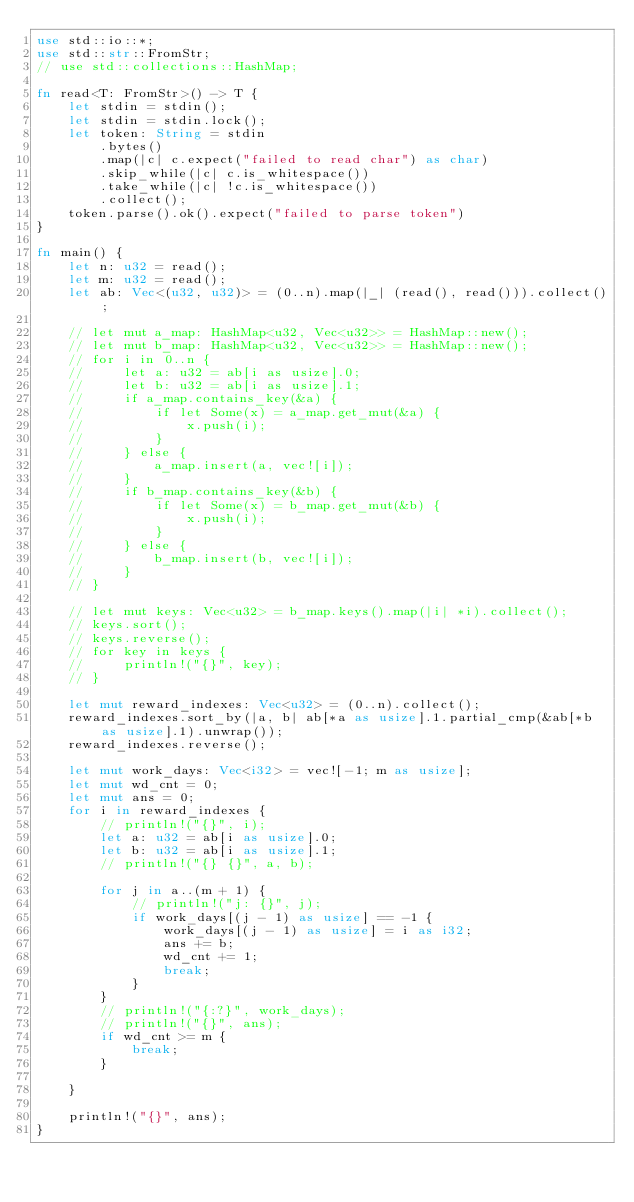Convert code to text. <code><loc_0><loc_0><loc_500><loc_500><_Rust_>use std::io::*;
use std::str::FromStr;
// use std::collections::HashMap;

fn read<T: FromStr>() -> T {
    let stdin = stdin();
    let stdin = stdin.lock();
    let token: String = stdin
        .bytes()
        .map(|c| c.expect("failed to read char") as char) 
        .skip_while(|c| c.is_whitespace())
        .take_while(|c| !c.is_whitespace())
        .collect();
    token.parse().ok().expect("failed to parse token")
}

fn main() {
    let n: u32 = read();
    let m: u32 = read();
    let ab: Vec<(u32, u32)> = (0..n).map(|_| (read(), read())).collect();

    // let mut a_map: HashMap<u32, Vec<u32>> = HashMap::new();
    // let mut b_map: HashMap<u32, Vec<u32>> = HashMap::new();
    // for i in 0..n {
    //     let a: u32 = ab[i as usize].0;
    //     let b: u32 = ab[i as usize].1;
    //     if a_map.contains_key(&a) {
    //         if let Some(x) = a_map.get_mut(&a) {
    //             x.push(i);
    //         }
    //     } else {
    //         a_map.insert(a, vec![i]);
    //     }
    //     if b_map.contains_key(&b) {
    //         if let Some(x) = b_map.get_mut(&b) {
    //             x.push(i);
    //         }
    //     } else {
    //         b_map.insert(b, vec![i]);
    //     }
    // }

    // let mut keys: Vec<u32> = b_map.keys().map(|i| *i).collect();
    // keys.sort();
    // keys.reverse();
    // for key in keys {
    //     println!("{}", key);
    // }

    let mut reward_indexes: Vec<u32> = (0..n).collect();
    reward_indexes.sort_by(|a, b| ab[*a as usize].1.partial_cmp(&ab[*b as usize].1).unwrap());
    reward_indexes.reverse();

    let mut work_days: Vec<i32> = vec![-1; m as usize];
    let mut wd_cnt = 0;
    let mut ans = 0;
    for i in reward_indexes {
        // println!("{}", i);
        let a: u32 = ab[i as usize].0;
        let b: u32 = ab[i as usize].1;
        // println!("{} {}", a, b);

        for j in a..(m + 1) {
            // println!("j: {}", j);
            if work_days[(j - 1) as usize] == -1 {
                work_days[(j - 1) as usize] = i as i32;
                ans += b;
                wd_cnt += 1;
                break;
            }   
        }
        // println!("{:?}", work_days);
        // println!("{}", ans);
        if wd_cnt >= m {
            break;
        }

    }

    println!("{}", ans);
}
</code> 